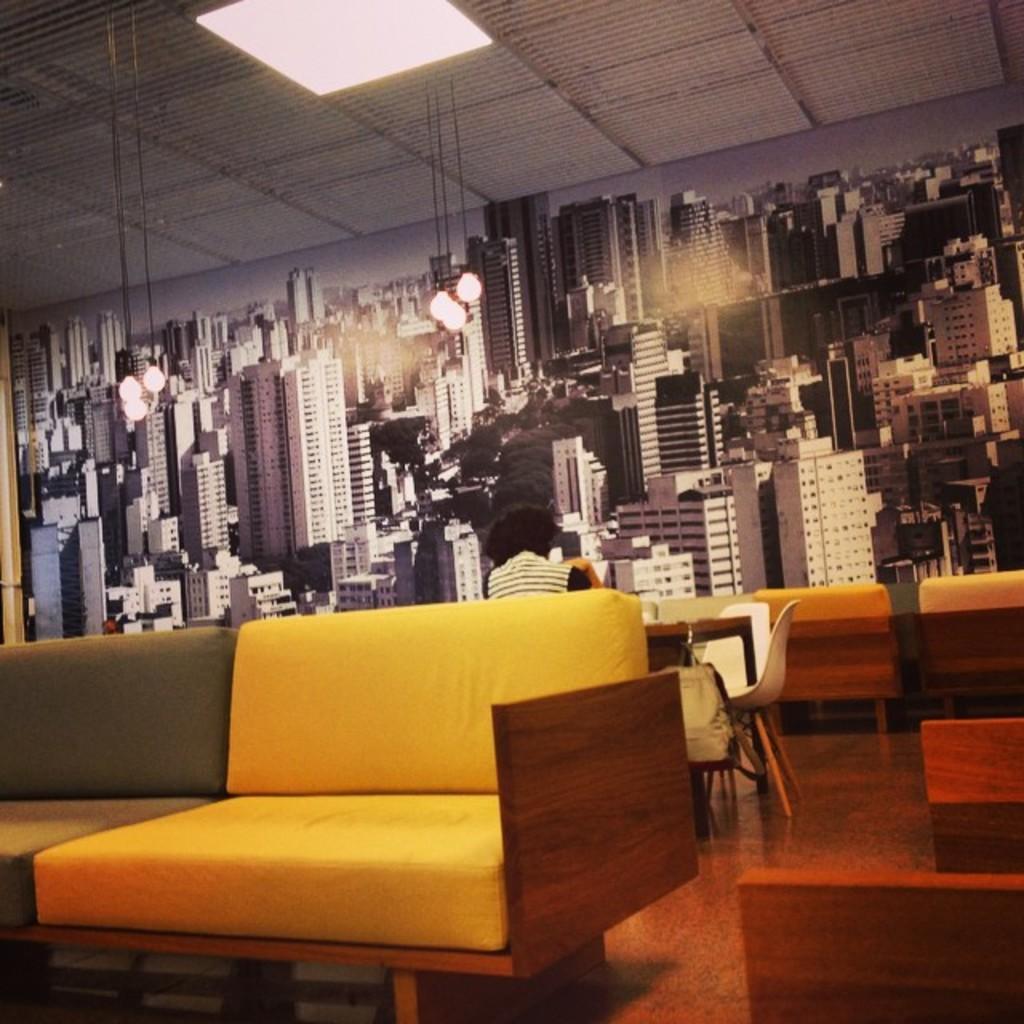Could you give a brief overview of what you see in this image? In the center we can see one person is sitting in front of table. Here in front we can see the couch. And coming to the background we can see the wall. 